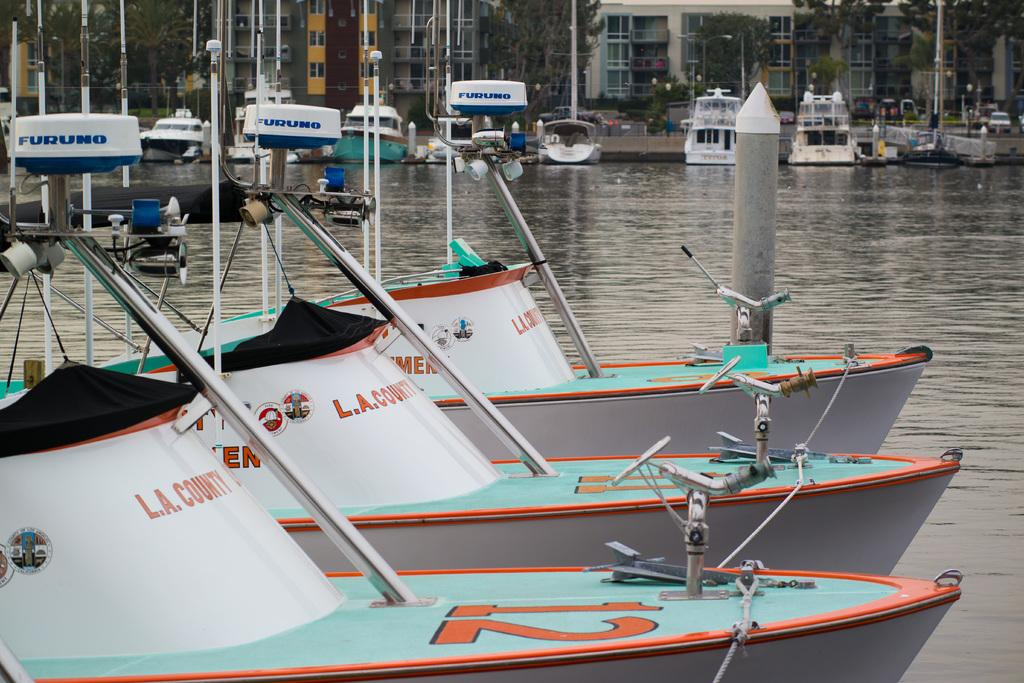What is in the water in the image? There are boats in the water in the image. What can be seen behind the boats? There are trees visible behind the boats. What structures are visible in the image? There are poles and buildings visible in the image. What is parked on a path in the image? A vehicle is parked on a path in the image. What type of temper does the snail have in the image? There is no snail present in the image, so it is not possible to determine its temper. What is the snail using to store its food in the image? There is no snail or jar present in the image. 